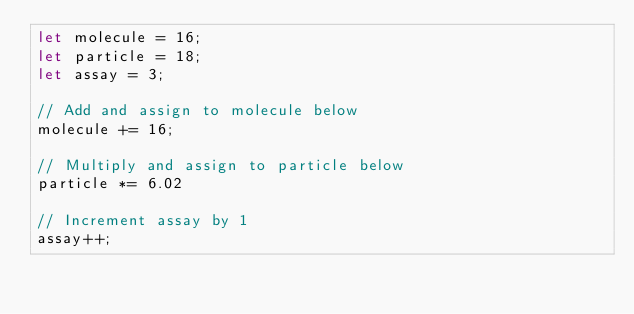<code> <loc_0><loc_0><loc_500><loc_500><_JavaScript_>let molecule = 16;
let particle = 18;
let assay = 3;

// Add and assign to molecule below
molecule += 16;

// Multiply and assign to particle below
particle *= 6.02

// Increment assay by 1
assay++;
</code> 